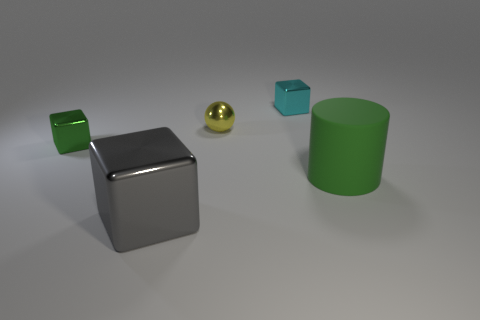Add 3 big cylinders. How many objects exist? 8 Subtract all balls. How many objects are left? 4 Add 3 cyan things. How many cyan things are left? 4 Add 3 tiny green shiny objects. How many tiny green shiny objects exist? 4 Subtract 0 gray spheres. How many objects are left? 5 Subtract all small blue matte cubes. Subtract all big gray things. How many objects are left? 4 